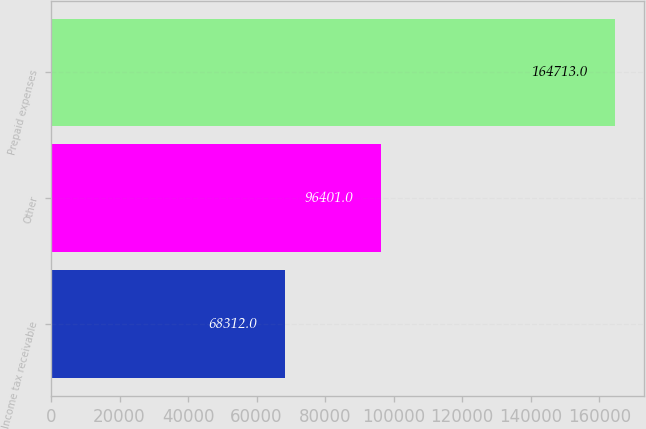<chart> <loc_0><loc_0><loc_500><loc_500><bar_chart><fcel>Income tax receivable<fcel>Other<fcel>Prepaid expenses<nl><fcel>68312<fcel>96401<fcel>164713<nl></chart> 